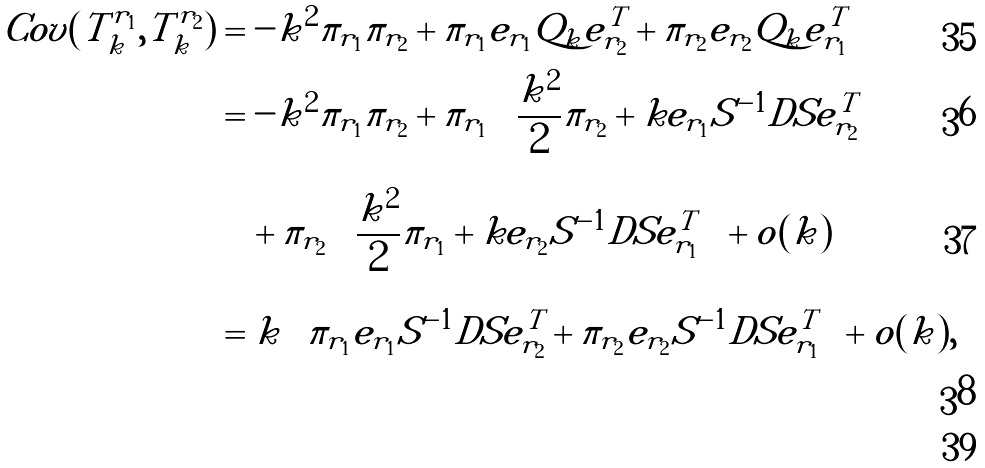Convert formula to latex. <formula><loc_0><loc_0><loc_500><loc_500>C o v ( T ^ { r _ { 1 } } _ { k } , T ^ { r _ { 2 } } _ { k } ) & = - k ^ { 2 } \pi _ { r _ { 1 } } \pi _ { r _ { 2 } } + \pi _ { r _ { 1 } } e _ { r _ { 1 } } Q _ { k } e _ { r _ { 2 } } ^ { T } + \pi _ { r _ { 2 } } e _ { r _ { 2 } } Q _ { k } e _ { r _ { 1 } } ^ { T } \\ & = - k ^ { 2 } \pi _ { r _ { 1 } } \pi _ { r _ { 2 } } + \pi _ { r _ { 1 } } \left ( \frac { k ^ { 2 } } { 2 } \pi _ { r _ { 2 } } + k e _ { r _ { 1 } } S ^ { - 1 } D S e _ { r _ { 2 } } ^ { T } \right ) \\ & \quad + \pi _ { r _ { 2 } } \left ( \frac { k ^ { 2 } } { 2 } \pi _ { r _ { 1 } } + k e _ { r _ { 2 } } S ^ { - 1 } D S e _ { r _ { 1 } } ^ { T } \right ) + o ( k ) \\ & = k \left ( \pi _ { r _ { 1 } } e _ { r _ { 1 } } S ^ { - 1 } D S e _ { r _ { 2 } } ^ { T } + \pi _ { r _ { 2 } } e _ { r _ { 2 } } S ^ { - 1 } D S e _ { r _ { 1 } } ^ { T } \right ) + o ( k ) , \\</formula> 